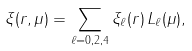<formula> <loc_0><loc_0><loc_500><loc_500>\xi ( r , \mu ) = \sum _ { \ell = 0 , 2 , 4 } \xi _ { \ell } ( r ) \, L _ { \ell } ( \mu ) ,</formula> 